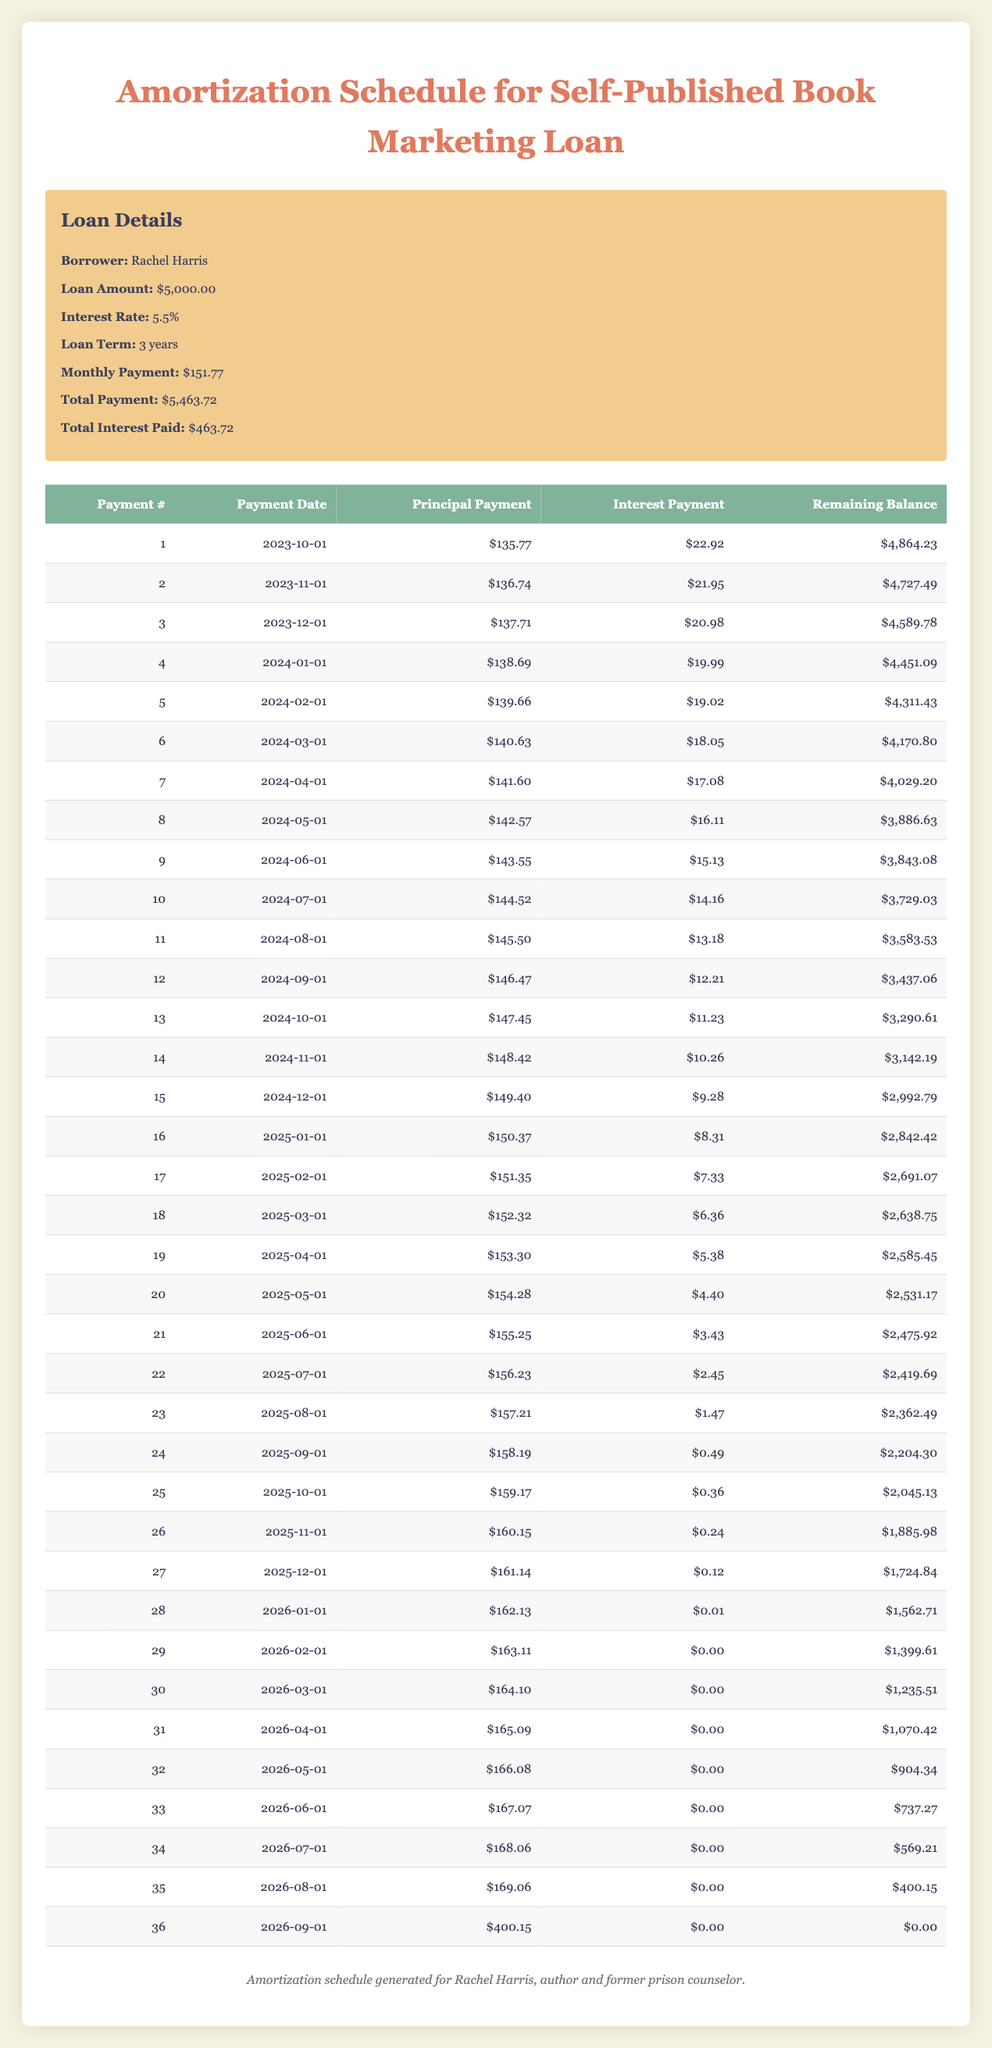What is the total amount paid in interest over the loan term? The total amount of interest paid is stated in the loan details as $463.72. This value does not require further calculations as it is given directly in the table.
Answer: 463.72 What is the monthly payment amount for this loan? The monthly payment amount is also provided in the loan details section of the table; it is stated as $151.77. This is a straightforward retrieval question since the value is right there in the table.
Answer: 151.77 How much was the principal payment in the third payment due on December 1, 2023? In the amortization schedule, for payment number 3, the principal payment specifically noted is $137.71. Thus, this value is extracted from the corresponding row directly without any additional calculation.
Answer: 137.71 What is the remaining balance after the 10th payment? The remaining balance after the 10th payment is stated in the amortization schedule as $3,729.03. This is directly referenced from the corresponding line of the table, making it a simple retrieval question.
Answer: 3729.03 Which month had the lowest interest payment, and what was that amount? To find the month with the lowest interest payment, look through the interest payment column in the schedule. The lowest amount is $0.00, which occurs during the 29th and 30th payments on February 1, 2026, and March 1, 2026. This means the interest payment fell to zero in those months.
Answer: February 2026, 0.00 What is the difference in the principal payment amount between the 15th and 20th payments? From the amortization schedule, the principal payment for the 15th payment is $149.40 and for the 20th payment is $154.28. The difference is calculated as $154.28 - $149.40 = $4.88. Therefore, this represents the amount by which the principal payment increases between these two payments.
Answer: 4.88 Did Rachel make any payments that were less than $5 in interest? By examining the interest payment column, we can see that there were interest payments lower than $5. Specifically, payments 20, 21, 22, 23, 24, and 25 all had interest payments below $5, confirming this statement is true.
Answer: Yes What is the average principal payment across the first six payments? The principal payments for the first six payments are as follows: $135.77, $136.74, $137.71, $138.69, $139.66, and $140.63. To find the average, sum them up: $135.77 + $136.74 + $137.71 + $138.69 + $139.66 + $140.63 = $828.20, and then divide by 6. Thus, the average principal payment equals $828.20 / 6 = $138.03.
Answer: 138.03 When will Rachel complete her loan payments? By reviewing the amortization schedule, we see the last payment occurs on September 1, 2026, at which point the remaining balance reaches $0.00, indicating the loan will be fully paid off at this date.
Answer: September 1, 2026 